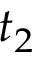<formula> <loc_0><loc_0><loc_500><loc_500>t _ { 2 }</formula> 